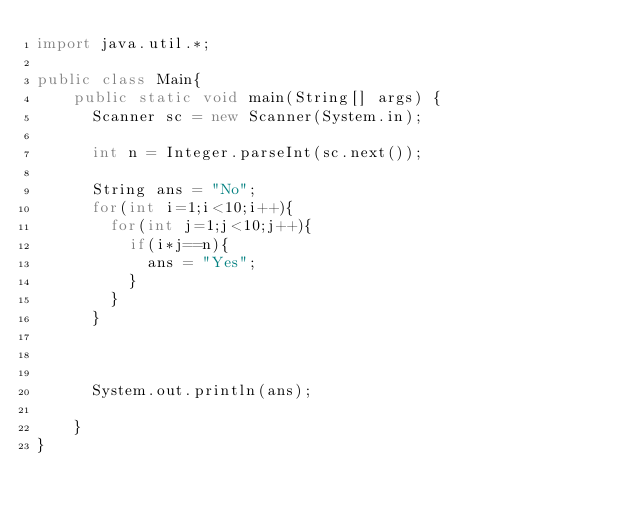<code> <loc_0><loc_0><loc_500><loc_500><_Java_>import java.util.*;

public class Main{
    public static void main(String[] args) {
      Scanner sc = new Scanner(System.in);

      int n = Integer.parseInt(sc.next());

      String ans = "No";
      for(int i=1;i<10;i++){
        for(int j=1;j<10;j++){
          if(i*j==n){
            ans = "Yes";
          }
        }
      }



      System.out.println(ans);

    }
}
</code> 